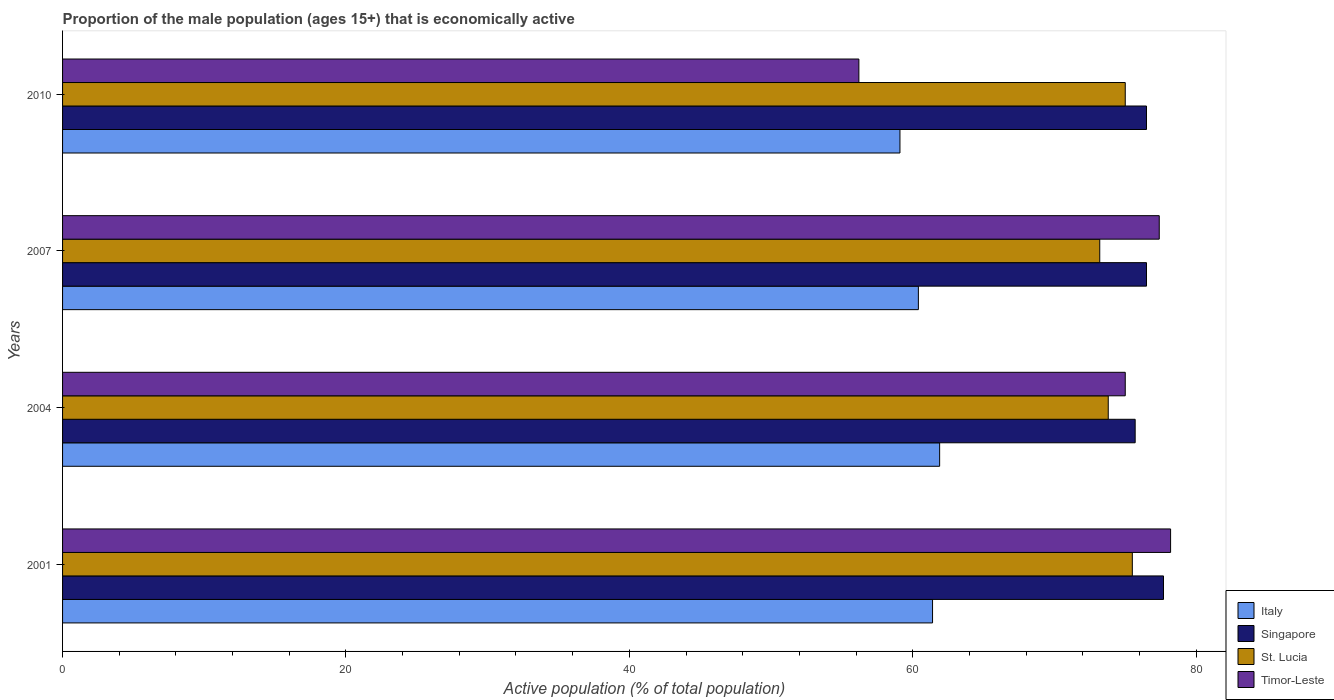How many different coloured bars are there?
Offer a terse response. 4. How many groups of bars are there?
Provide a succinct answer. 4. Are the number of bars per tick equal to the number of legend labels?
Give a very brief answer. Yes. How many bars are there on the 2nd tick from the bottom?
Your answer should be compact. 4. In how many cases, is the number of bars for a given year not equal to the number of legend labels?
Offer a very short reply. 0. What is the proportion of the male population that is economically active in St. Lucia in 2007?
Provide a succinct answer. 73.2. Across all years, what is the maximum proportion of the male population that is economically active in Singapore?
Make the answer very short. 77.7. Across all years, what is the minimum proportion of the male population that is economically active in Singapore?
Offer a terse response. 75.7. What is the total proportion of the male population that is economically active in Singapore in the graph?
Make the answer very short. 306.4. What is the difference between the proportion of the male population that is economically active in Singapore in 2004 and that in 2010?
Provide a short and direct response. -0.8. What is the difference between the proportion of the male population that is economically active in Italy in 2004 and the proportion of the male population that is economically active in St. Lucia in 2001?
Keep it short and to the point. -13.6. What is the average proportion of the male population that is economically active in Singapore per year?
Your response must be concise. 76.6. In the year 2004, what is the difference between the proportion of the male population that is economically active in St. Lucia and proportion of the male population that is economically active in Singapore?
Give a very brief answer. -1.9. In how many years, is the proportion of the male population that is economically active in St. Lucia greater than 24 %?
Offer a terse response. 4. What is the ratio of the proportion of the male population that is economically active in Italy in 2001 to that in 2007?
Give a very brief answer. 1.02. Is the proportion of the male population that is economically active in Timor-Leste in 2004 less than that in 2010?
Provide a short and direct response. No. Is the difference between the proportion of the male population that is economically active in St. Lucia in 2007 and 2010 greater than the difference between the proportion of the male population that is economically active in Singapore in 2007 and 2010?
Make the answer very short. No. What is the difference between the highest and the second highest proportion of the male population that is economically active in Timor-Leste?
Give a very brief answer. 0.8. What is the difference between the highest and the lowest proportion of the male population that is economically active in Singapore?
Offer a very short reply. 2. Is the sum of the proportion of the male population that is economically active in Timor-Leste in 2007 and 2010 greater than the maximum proportion of the male population that is economically active in St. Lucia across all years?
Ensure brevity in your answer.  Yes. Is it the case that in every year, the sum of the proportion of the male population that is economically active in Timor-Leste and proportion of the male population that is economically active in Singapore is greater than the sum of proportion of the male population that is economically active in Italy and proportion of the male population that is economically active in St. Lucia?
Ensure brevity in your answer.  No. What does the 2nd bar from the top in 2007 represents?
Keep it short and to the point. St. Lucia. What does the 4th bar from the bottom in 2010 represents?
Provide a succinct answer. Timor-Leste. How many bars are there?
Your answer should be very brief. 16. Are all the bars in the graph horizontal?
Provide a succinct answer. Yes. What is the difference between two consecutive major ticks on the X-axis?
Give a very brief answer. 20. Does the graph contain any zero values?
Your response must be concise. No. How many legend labels are there?
Keep it short and to the point. 4. How are the legend labels stacked?
Offer a terse response. Vertical. What is the title of the graph?
Offer a very short reply. Proportion of the male population (ages 15+) that is economically active. What is the label or title of the X-axis?
Provide a short and direct response. Active population (% of total population). What is the Active population (% of total population) in Italy in 2001?
Offer a terse response. 61.4. What is the Active population (% of total population) of Singapore in 2001?
Keep it short and to the point. 77.7. What is the Active population (% of total population) in St. Lucia in 2001?
Your response must be concise. 75.5. What is the Active population (% of total population) of Timor-Leste in 2001?
Your response must be concise. 78.2. What is the Active population (% of total population) of Italy in 2004?
Provide a succinct answer. 61.9. What is the Active population (% of total population) of Singapore in 2004?
Ensure brevity in your answer.  75.7. What is the Active population (% of total population) in St. Lucia in 2004?
Offer a very short reply. 73.8. What is the Active population (% of total population) in Timor-Leste in 2004?
Your answer should be very brief. 75. What is the Active population (% of total population) in Italy in 2007?
Provide a succinct answer. 60.4. What is the Active population (% of total population) in Singapore in 2007?
Keep it short and to the point. 76.5. What is the Active population (% of total population) of St. Lucia in 2007?
Offer a very short reply. 73.2. What is the Active population (% of total population) of Timor-Leste in 2007?
Provide a short and direct response. 77.4. What is the Active population (% of total population) of Italy in 2010?
Your response must be concise. 59.1. What is the Active population (% of total population) of Singapore in 2010?
Ensure brevity in your answer.  76.5. What is the Active population (% of total population) in Timor-Leste in 2010?
Make the answer very short. 56.2. Across all years, what is the maximum Active population (% of total population) of Italy?
Offer a very short reply. 61.9. Across all years, what is the maximum Active population (% of total population) in Singapore?
Your answer should be very brief. 77.7. Across all years, what is the maximum Active population (% of total population) of St. Lucia?
Provide a short and direct response. 75.5. Across all years, what is the maximum Active population (% of total population) of Timor-Leste?
Your answer should be very brief. 78.2. Across all years, what is the minimum Active population (% of total population) of Italy?
Your answer should be very brief. 59.1. Across all years, what is the minimum Active population (% of total population) of Singapore?
Ensure brevity in your answer.  75.7. Across all years, what is the minimum Active population (% of total population) in St. Lucia?
Your answer should be very brief. 73.2. Across all years, what is the minimum Active population (% of total population) of Timor-Leste?
Offer a very short reply. 56.2. What is the total Active population (% of total population) of Italy in the graph?
Offer a very short reply. 242.8. What is the total Active population (% of total population) in Singapore in the graph?
Provide a succinct answer. 306.4. What is the total Active population (% of total population) in St. Lucia in the graph?
Your response must be concise. 297.5. What is the total Active population (% of total population) of Timor-Leste in the graph?
Give a very brief answer. 286.8. What is the difference between the Active population (% of total population) in Italy in 2001 and that in 2004?
Offer a very short reply. -0.5. What is the difference between the Active population (% of total population) in St. Lucia in 2001 and that in 2004?
Your response must be concise. 1.7. What is the difference between the Active population (% of total population) of Timor-Leste in 2001 and that in 2004?
Ensure brevity in your answer.  3.2. What is the difference between the Active population (% of total population) of Singapore in 2001 and that in 2007?
Provide a short and direct response. 1.2. What is the difference between the Active population (% of total population) in Singapore in 2001 and that in 2010?
Ensure brevity in your answer.  1.2. What is the difference between the Active population (% of total population) in St. Lucia in 2001 and that in 2010?
Give a very brief answer. 0.5. What is the difference between the Active population (% of total population) of Timor-Leste in 2001 and that in 2010?
Offer a terse response. 22. What is the difference between the Active population (% of total population) of Singapore in 2004 and that in 2007?
Give a very brief answer. -0.8. What is the difference between the Active population (% of total population) of St. Lucia in 2004 and that in 2007?
Provide a succinct answer. 0.6. What is the difference between the Active population (% of total population) of Italy in 2004 and that in 2010?
Provide a short and direct response. 2.8. What is the difference between the Active population (% of total population) in Singapore in 2004 and that in 2010?
Give a very brief answer. -0.8. What is the difference between the Active population (% of total population) of St. Lucia in 2004 and that in 2010?
Your response must be concise. -1.2. What is the difference between the Active population (% of total population) in Timor-Leste in 2004 and that in 2010?
Ensure brevity in your answer.  18.8. What is the difference between the Active population (% of total population) of Italy in 2007 and that in 2010?
Make the answer very short. 1.3. What is the difference between the Active population (% of total population) of Timor-Leste in 2007 and that in 2010?
Your answer should be very brief. 21.2. What is the difference between the Active population (% of total population) in Italy in 2001 and the Active population (% of total population) in Singapore in 2004?
Your answer should be very brief. -14.3. What is the difference between the Active population (% of total population) in Italy in 2001 and the Active population (% of total population) in Timor-Leste in 2004?
Your response must be concise. -13.6. What is the difference between the Active population (% of total population) of St. Lucia in 2001 and the Active population (% of total population) of Timor-Leste in 2004?
Ensure brevity in your answer.  0.5. What is the difference between the Active population (% of total population) of Italy in 2001 and the Active population (% of total population) of Singapore in 2007?
Offer a terse response. -15.1. What is the difference between the Active population (% of total population) in Italy in 2001 and the Active population (% of total population) in St. Lucia in 2007?
Keep it short and to the point. -11.8. What is the difference between the Active population (% of total population) of Italy in 2001 and the Active population (% of total population) of Singapore in 2010?
Provide a succinct answer. -15.1. What is the difference between the Active population (% of total population) of Italy in 2001 and the Active population (% of total population) of Timor-Leste in 2010?
Make the answer very short. 5.2. What is the difference between the Active population (% of total population) in Singapore in 2001 and the Active population (% of total population) in St. Lucia in 2010?
Provide a short and direct response. 2.7. What is the difference between the Active population (% of total population) in Singapore in 2001 and the Active population (% of total population) in Timor-Leste in 2010?
Make the answer very short. 21.5. What is the difference between the Active population (% of total population) in St. Lucia in 2001 and the Active population (% of total population) in Timor-Leste in 2010?
Your answer should be very brief. 19.3. What is the difference between the Active population (% of total population) of Italy in 2004 and the Active population (% of total population) of Singapore in 2007?
Keep it short and to the point. -14.6. What is the difference between the Active population (% of total population) of Italy in 2004 and the Active population (% of total population) of Timor-Leste in 2007?
Your answer should be compact. -15.5. What is the difference between the Active population (% of total population) in Singapore in 2004 and the Active population (% of total population) in St. Lucia in 2007?
Your answer should be compact. 2.5. What is the difference between the Active population (% of total population) in Italy in 2004 and the Active population (% of total population) in Singapore in 2010?
Offer a very short reply. -14.6. What is the difference between the Active population (% of total population) in Singapore in 2004 and the Active population (% of total population) in St. Lucia in 2010?
Your answer should be compact. 0.7. What is the difference between the Active population (% of total population) of St. Lucia in 2004 and the Active population (% of total population) of Timor-Leste in 2010?
Offer a very short reply. 17.6. What is the difference between the Active population (% of total population) in Italy in 2007 and the Active population (% of total population) in Singapore in 2010?
Provide a short and direct response. -16.1. What is the difference between the Active population (% of total population) in Italy in 2007 and the Active population (% of total population) in St. Lucia in 2010?
Your response must be concise. -14.6. What is the difference between the Active population (% of total population) in Italy in 2007 and the Active population (% of total population) in Timor-Leste in 2010?
Ensure brevity in your answer.  4.2. What is the difference between the Active population (% of total population) in Singapore in 2007 and the Active population (% of total population) in St. Lucia in 2010?
Provide a succinct answer. 1.5. What is the difference between the Active population (% of total population) in Singapore in 2007 and the Active population (% of total population) in Timor-Leste in 2010?
Ensure brevity in your answer.  20.3. What is the average Active population (% of total population) in Italy per year?
Offer a very short reply. 60.7. What is the average Active population (% of total population) in Singapore per year?
Your response must be concise. 76.6. What is the average Active population (% of total population) in St. Lucia per year?
Offer a terse response. 74.38. What is the average Active population (% of total population) of Timor-Leste per year?
Provide a short and direct response. 71.7. In the year 2001, what is the difference between the Active population (% of total population) in Italy and Active population (% of total population) in Singapore?
Your answer should be compact. -16.3. In the year 2001, what is the difference between the Active population (% of total population) of Italy and Active population (% of total population) of St. Lucia?
Make the answer very short. -14.1. In the year 2001, what is the difference between the Active population (% of total population) in Italy and Active population (% of total population) in Timor-Leste?
Offer a terse response. -16.8. In the year 2001, what is the difference between the Active population (% of total population) of Singapore and Active population (% of total population) of Timor-Leste?
Your answer should be very brief. -0.5. In the year 2004, what is the difference between the Active population (% of total population) in Italy and Active population (% of total population) in Timor-Leste?
Make the answer very short. -13.1. In the year 2004, what is the difference between the Active population (% of total population) in Singapore and Active population (% of total population) in St. Lucia?
Provide a short and direct response. 1.9. In the year 2004, what is the difference between the Active population (% of total population) in Singapore and Active population (% of total population) in Timor-Leste?
Provide a short and direct response. 0.7. In the year 2007, what is the difference between the Active population (% of total population) of Italy and Active population (% of total population) of Singapore?
Your answer should be very brief. -16.1. In the year 2007, what is the difference between the Active population (% of total population) in Italy and Active population (% of total population) in Timor-Leste?
Your answer should be compact. -17. In the year 2007, what is the difference between the Active population (% of total population) of Singapore and Active population (% of total population) of St. Lucia?
Offer a terse response. 3.3. In the year 2007, what is the difference between the Active population (% of total population) in Singapore and Active population (% of total population) in Timor-Leste?
Offer a terse response. -0.9. In the year 2007, what is the difference between the Active population (% of total population) of St. Lucia and Active population (% of total population) of Timor-Leste?
Make the answer very short. -4.2. In the year 2010, what is the difference between the Active population (% of total population) of Italy and Active population (% of total population) of Singapore?
Your response must be concise. -17.4. In the year 2010, what is the difference between the Active population (% of total population) of Italy and Active population (% of total population) of St. Lucia?
Ensure brevity in your answer.  -15.9. In the year 2010, what is the difference between the Active population (% of total population) in Italy and Active population (% of total population) in Timor-Leste?
Offer a very short reply. 2.9. In the year 2010, what is the difference between the Active population (% of total population) of Singapore and Active population (% of total population) of St. Lucia?
Your answer should be very brief. 1.5. In the year 2010, what is the difference between the Active population (% of total population) in Singapore and Active population (% of total population) in Timor-Leste?
Ensure brevity in your answer.  20.3. What is the ratio of the Active population (% of total population) of Italy in 2001 to that in 2004?
Your answer should be compact. 0.99. What is the ratio of the Active population (% of total population) of Singapore in 2001 to that in 2004?
Give a very brief answer. 1.03. What is the ratio of the Active population (% of total population) of St. Lucia in 2001 to that in 2004?
Your response must be concise. 1.02. What is the ratio of the Active population (% of total population) in Timor-Leste in 2001 to that in 2004?
Offer a very short reply. 1.04. What is the ratio of the Active population (% of total population) in Italy in 2001 to that in 2007?
Provide a succinct answer. 1.02. What is the ratio of the Active population (% of total population) in Singapore in 2001 to that in 2007?
Ensure brevity in your answer.  1.02. What is the ratio of the Active population (% of total population) of St. Lucia in 2001 to that in 2007?
Make the answer very short. 1.03. What is the ratio of the Active population (% of total population) of Timor-Leste in 2001 to that in 2007?
Ensure brevity in your answer.  1.01. What is the ratio of the Active population (% of total population) of Italy in 2001 to that in 2010?
Your response must be concise. 1.04. What is the ratio of the Active population (% of total population) of Singapore in 2001 to that in 2010?
Ensure brevity in your answer.  1.02. What is the ratio of the Active population (% of total population) of Timor-Leste in 2001 to that in 2010?
Your answer should be very brief. 1.39. What is the ratio of the Active population (% of total population) of Italy in 2004 to that in 2007?
Your answer should be very brief. 1.02. What is the ratio of the Active population (% of total population) of St. Lucia in 2004 to that in 2007?
Offer a very short reply. 1.01. What is the ratio of the Active population (% of total population) in Timor-Leste in 2004 to that in 2007?
Your response must be concise. 0.97. What is the ratio of the Active population (% of total population) of Italy in 2004 to that in 2010?
Your answer should be very brief. 1.05. What is the ratio of the Active population (% of total population) of Timor-Leste in 2004 to that in 2010?
Keep it short and to the point. 1.33. What is the ratio of the Active population (% of total population) in St. Lucia in 2007 to that in 2010?
Your answer should be very brief. 0.98. What is the ratio of the Active population (% of total population) of Timor-Leste in 2007 to that in 2010?
Offer a terse response. 1.38. What is the difference between the highest and the second highest Active population (% of total population) in Italy?
Keep it short and to the point. 0.5. What is the difference between the highest and the second highest Active population (% of total population) in St. Lucia?
Provide a short and direct response. 0.5. What is the difference between the highest and the second highest Active population (% of total population) of Timor-Leste?
Make the answer very short. 0.8. What is the difference between the highest and the lowest Active population (% of total population) of Italy?
Make the answer very short. 2.8. 